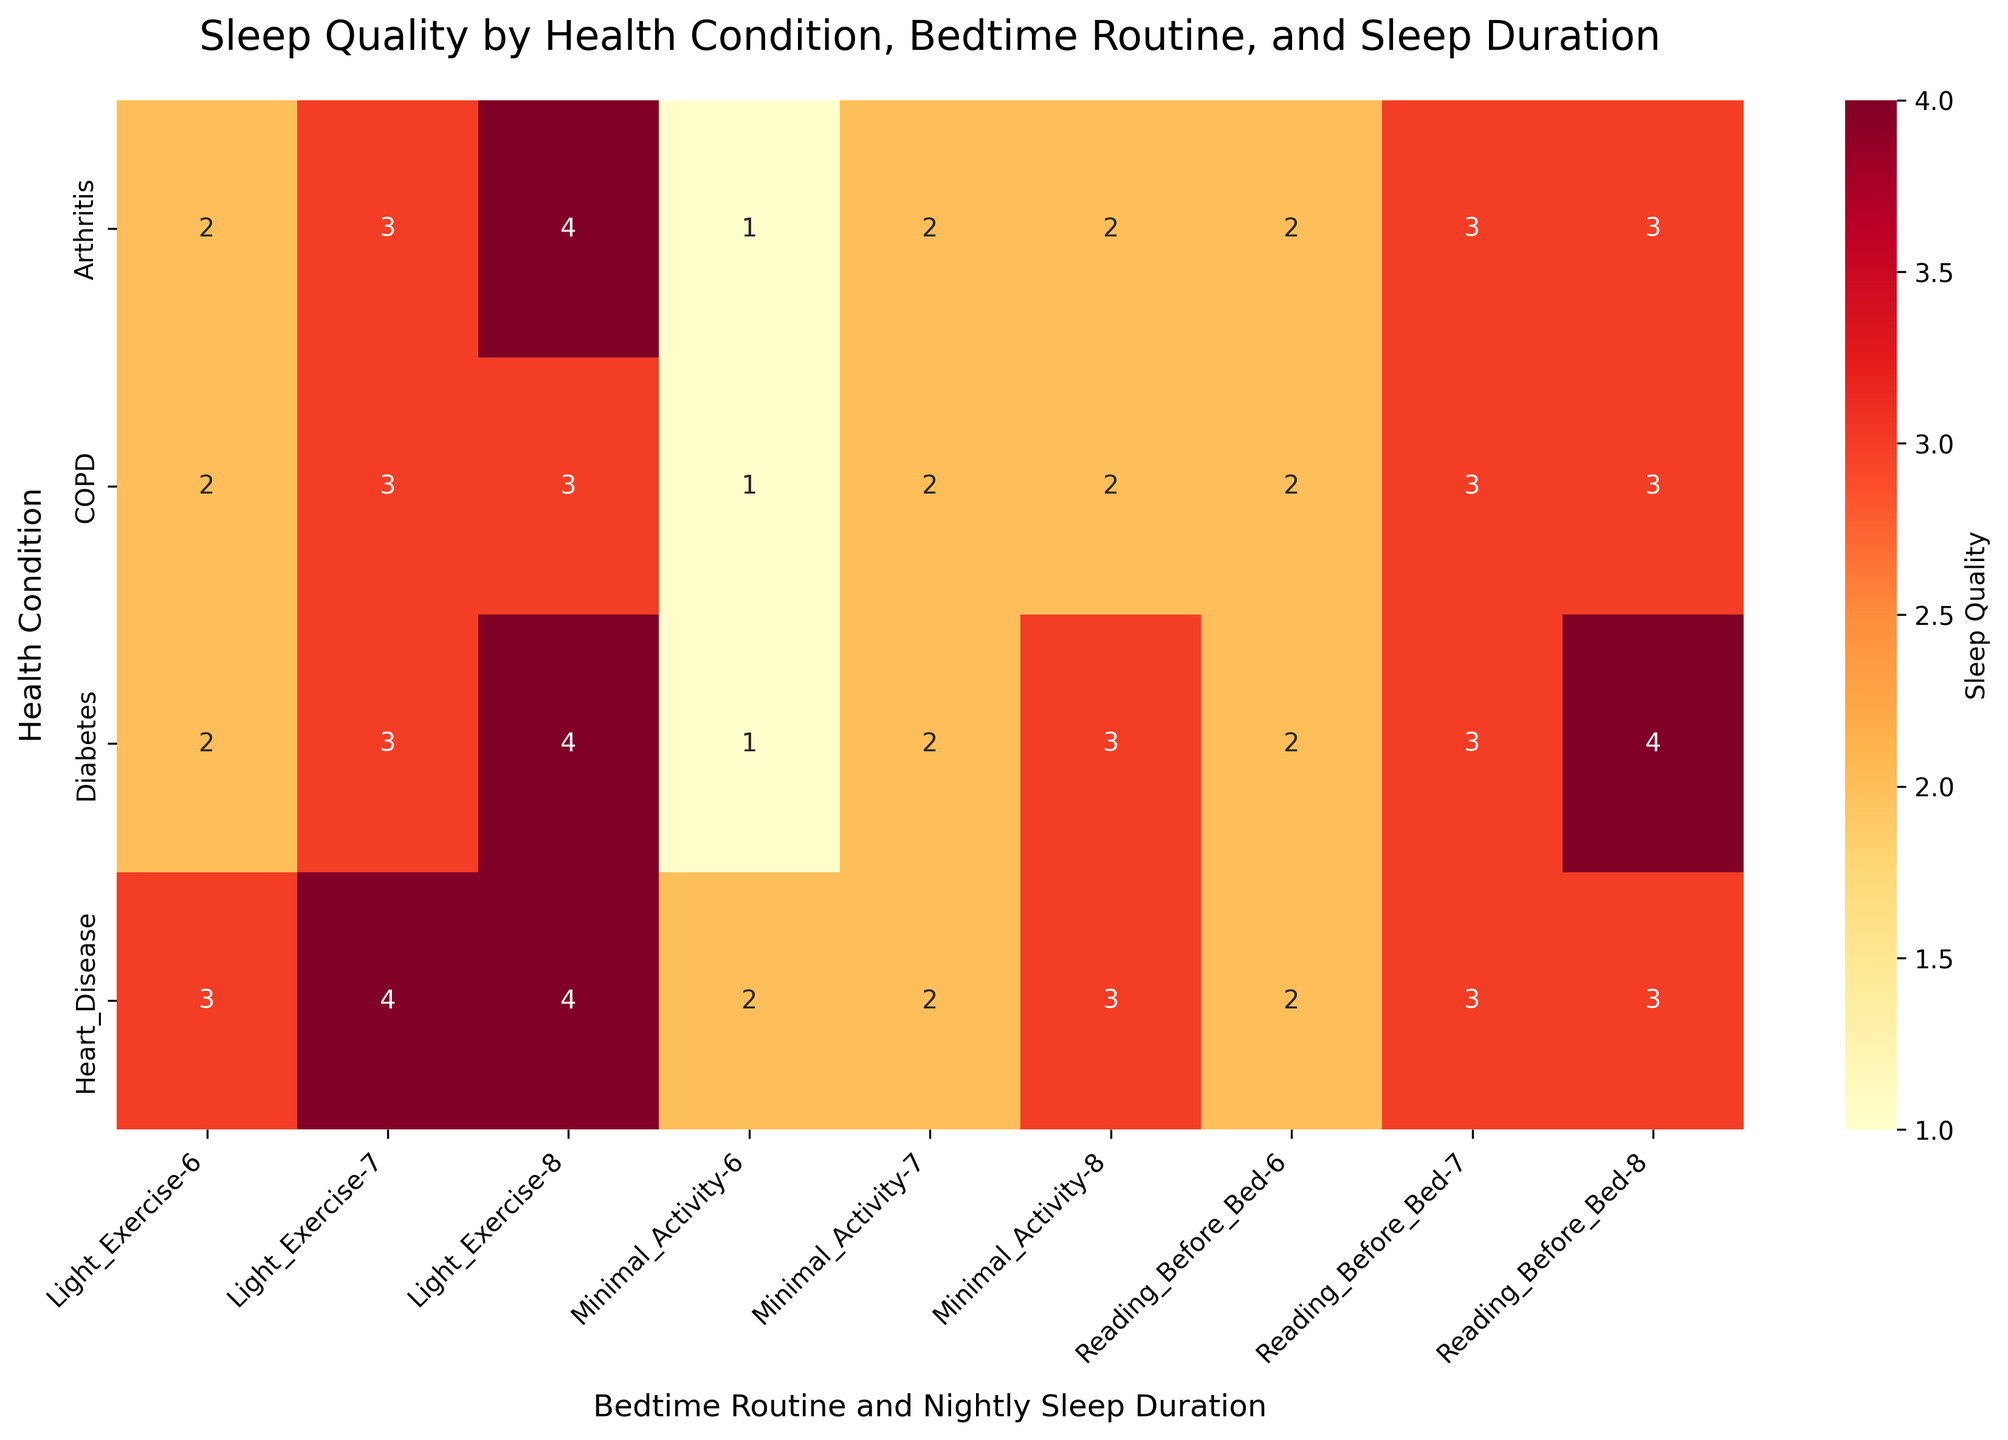What does the title of the heatmap say? The title of the heatmap is at the top of the figure and reads "Sleep Quality by Health Condition, Bedtime Routine, and Sleep Duration".
Answer: Sleep Quality by Health Condition, Bedtime Routine, and Sleep Duration Which bedtime routine shows the highest sleep quality for patients with diabetes? Looking at the heatmap, the highest sleep quality for diabetes, indicated by the darkest red color, corresponds to "Reading Before Bed" and "Light Exercise" routines for 8 hours of sleep.
Answer: Reading Before Bed and Light Exercise How does the sleep quality change for patients with heart disease when they do light exercise before bed? Based on the heatmap, patients with heart disease who do light exercise have fair sleep quality with 6 hours of sleep, very good sleep quality with 7 hours, and very good sleep quality with 8 hours.
Answer: It improves from good to very good as sleep duration increases For patients with COPD, what sleep quality is observed with minimal activity and 6 hours of sleep? The sleep quality for patients with COPD with minimal activity and 6 hours of sleep is indicated by the lightest color, representing "Poor".
Answer: Poor Compare the sleep quality for arthritis patients who read before bed and have 8 hours of sleep versus those who do minimal activity and have 8 hours of sleep. Patients with arthritis who read before bed have a sleep quality represented by "Good" (darker color), whereas those who do minimal activity have a "Fair" (lighter color) sleep quality.
Answer: Reading before bed results in better sleep quality Which health condition shows the best overall sleep quality for those doing light exercise before bed? For light exercise, patients with heart disease show the best overall sleep quality with very good sleep quality at both 7 and 8 hours of sleep.
Answer: Heart Disease How does the sleep quality for diabetes patients with 7 hours of sleep vary across different bedtime routines? Diabetes patients with 7 hours of sleep have fair sleep quality with minimal activity, good sleep quality with reading before bed, and good sleep quality with light exercise.
Answer: Fair with minimal activity, good with reading before bed and light exercise What sleep quality do patients with arthritis experience when doing minimal activity for 6 and 7 hours of sleep? For arthritis patients, minimal activity results in poor sleep quality for 6 hours of sleep and fair sleep quality for 7 hours of sleep.
Answer: Poor for 6 hours, fair for 7 hours For the patients with COPD, is there any routine that results in "Very Good" sleep quality? The heatmap does not show any "Very Good" sleep quality (darkest color) for COPD patients, regardless of the routine.
Answer: No What effect does an increase in nightly sleep duration from 6 to 8 hours have on sleep quality for patients with heart disease reading before bedtime? For patients with heart disease, reading before bedtime and increasing nightly sleep duration from 6 to 8 hours improves sleep quality from fair to good.
Answer: Improves from fair to good 